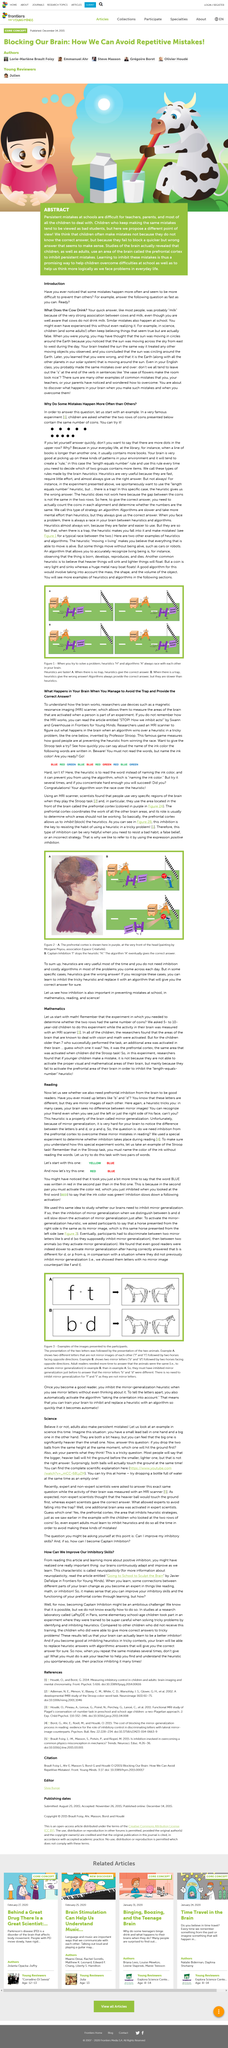Mention a couple of crucial points in this snapshot. Magnetic resonance imaging, commonly known as MRI, is a medical imaging technique that utilizes a powerful magnetic field, radio waves, and a computer to produce detailed images of the body's internal structures. It does not use ionizing radiation, as in X-rays or computed tomography (CT) scans, making it a safe and non-invasive diagnostic tool. In the Stroop test, the participant is required to name the color of the ink used in the printed words without reading the words themselves, despite the incongruity between the color of the ink and the word printed on it. The algorithm that accurately recognizes a living being is whether it is born, develops, reproduces, and dies. It is not necessary to inhibit mirror generalization in Example A because the letters F and T are not mirror letters. Researchers utilize MRI scanners to comprehend the functionalities of the brain. 